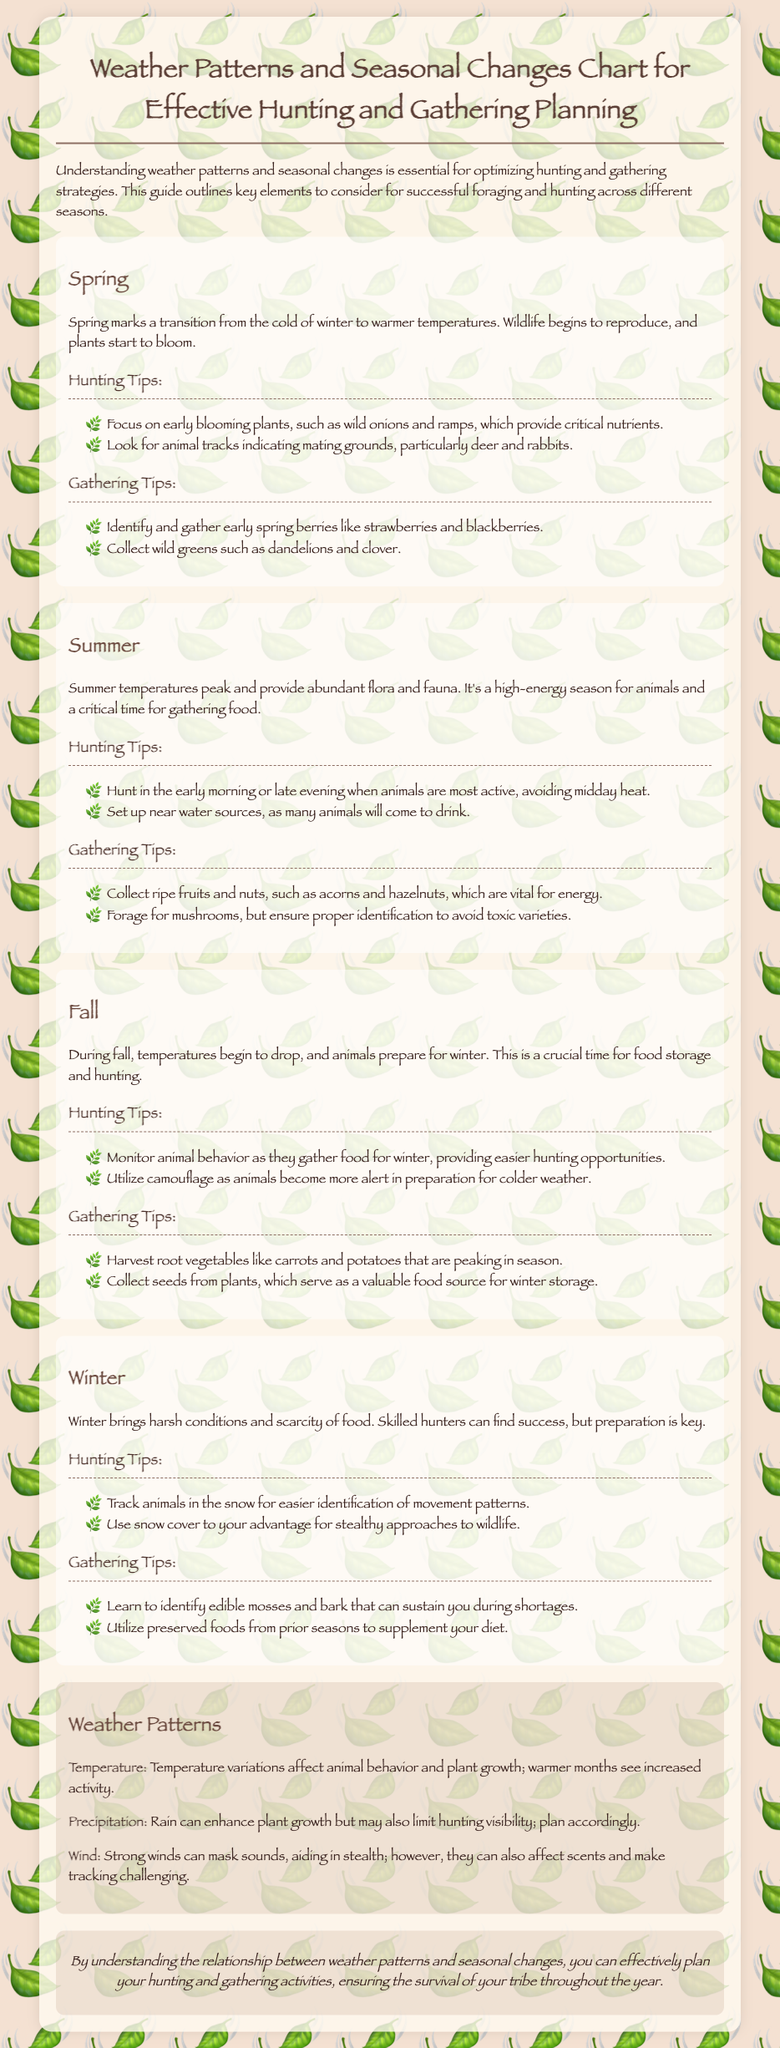What tips are suggested for hunting in Spring? The document outlines specific tips for hunting during Spring, including focusing on early blooming plants and looking for animal tracks.
Answer: Early blooming plants and animal tracks What type of vegetables should be harvested in Fall? The document specifies that root vegetables like carrots and potatoes should be harvested during the Fall season.
Answer: Root vegetables Which season sees the highest activity among animals? The document indicates that Summer is a high-energy season for animals, suggesting their increased activity.
Answer: Summer What are the key weather patterns affecting hunting and gathering? The document describes several weather patterns, including temperature, precipitation, and wind, that impact hunting and gathering.
Answer: Temperature, precipitation, wind What can help with stealth hunting in Winter? The document mentions using snow cover to your advantage for stealthy approaches during Winter.
Answer: Snow cover How should hunters adjust their plans for rainy weather? It is stated that rain can limit hunting visibility; therefore, hunters should plan accordingly when it rains.
Answer: Plan accordingly What springs forth during Spring that is critical for nutrients? The document highlights early blooming plants, specifically mentioning wild onions and ramps, in Spring that provide essential nutrients.
Answer: Wild onions and ramps What is suggested for gathering food during Winter? The document suggests identifying edible mosses and bark as options for gathering food during Winter shortages.
Answer: Edible mosses and bark 